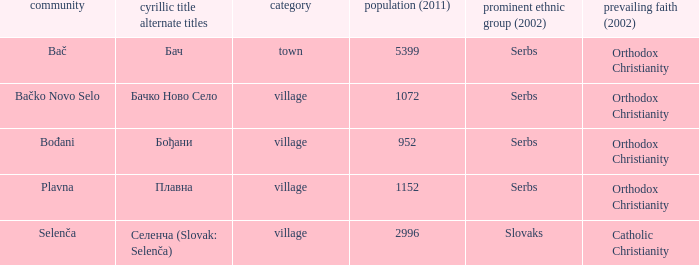What is the second way of writting плавна. Plavna. 